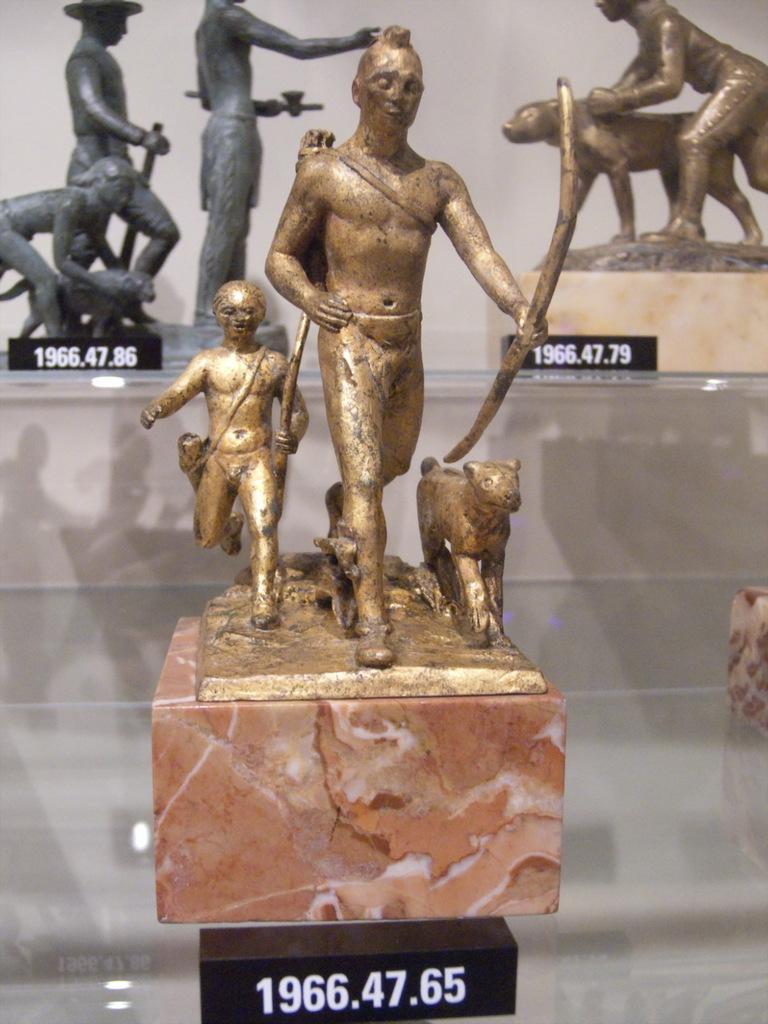Please provide a concise description of this image. In this image, in the middle there are some yellow color statues kept on the brown color table, in the background there are some gray color statues and there are some yellow color statues kept. 